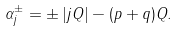<formula> <loc_0><loc_0><loc_500><loc_500>\alpha _ { j } ^ { \pm } = \pm \left | j Q \right | - ( p + q ) Q .</formula> 